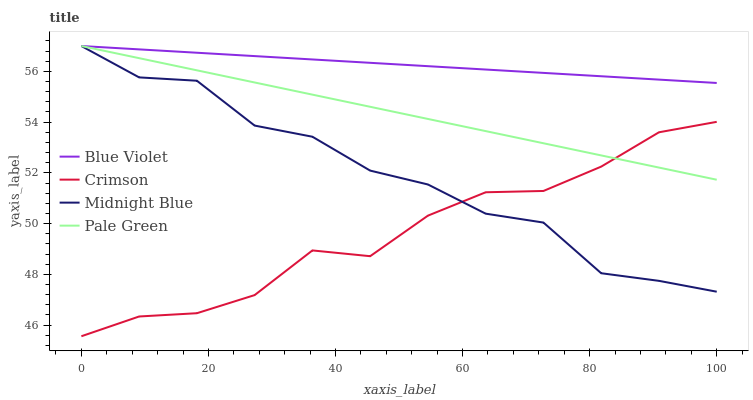Does Crimson have the minimum area under the curve?
Answer yes or no. Yes. Does Blue Violet have the maximum area under the curve?
Answer yes or no. Yes. Does Pale Green have the minimum area under the curve?
Answer yes or no. No. Does Pale Green have the maximum area under the curve?
Answer yes or no. No. Is Blue Violet the smoothest?
Answer yes or no. Yes. Is Midnight Blue the roughest?
Answer yes or no. Yes. Is Pale Green the smoothest?
Answer yes or no. No. Is Pale Green the roughest?
Answer yes or no. No. Does Crimson have the lowest value?
Answer yes or no. Yes. Does Pale Green have the lowest value?
Answer yes or no. No. Does Blue Violet have the highest value?
Answer yes or no. Yes. Is Crimson less than Blue Violet?
Answer yes or no. Yes. Is Blue Violet greater than Crimson?
Answer yes or no. Yes. Does Crimson intersect Pale Green?
Answer yes or no. Yes. Is Crimson less than Pale Green?
Answer yes or no. No. Is Crimson greater than Pale Green?
Answer yes or no. No. Does Crimson intersect Blue Violet?
Answer yes or no. No. 